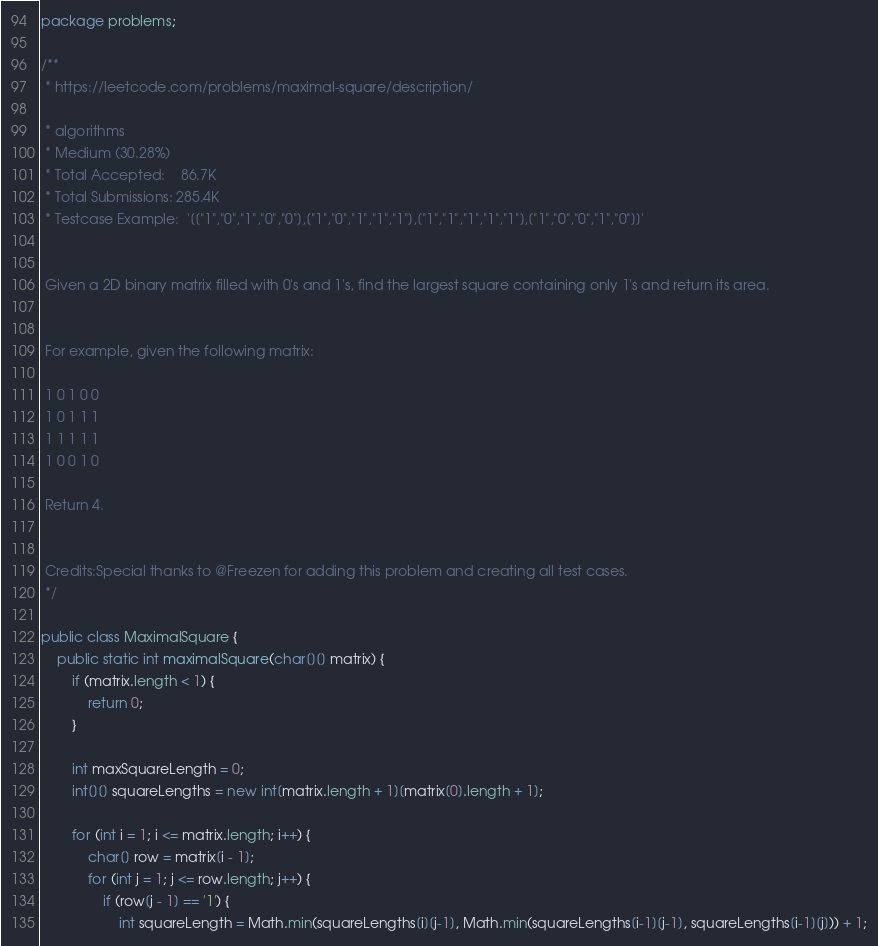<code> <loc_0><loc_0><loc_500><loc_500><_Java_>package problems;

/**
 * https://leetcode.com/problems/maximal-square/description/

 * algorithms
 * Medium (30.28%)
 * Total Accepted:    86.7K
 * Total Submissions: 285.4K
 * Testcase Example:  '[["1","0","1","0","0"],["1","0","1","1","1"],["1","1","1","1","1"],["1","0","0","1","0"]]'


 Given a 2D binary matrix filled with 0's and 1's, find the largest square containing only 1's and return its area.


 For example, given the following matrix:

 1 0 1 0 0
 1 0 1 1 1
 1 1 1 1 1
 1 0 0 1 0

 Return 4.


 Credits:Special thanks to @Freezen for adding this problem and creating all test cases.
 */

public class MaximalSquare {
    public static int maximalSquare(char[][] matrix) {
        if (matrix.length < 1) {
            return 0;
        }

        int maxSquareLength = 0;
        int[][] squareLengths = new int[matrix.length + 1][matrix[0].length + 1];

        for (int i = 1; i <= matrix.length; i++) {
            char[] row = matrix[i - 1];
            for (int j = 1; j <= row.length; j++) {
                if (row[j - 1] == '1') {
                    int squareLength = Math.min(squareLengths[i][j-1], Math.min(squareLengths[i-1][j-1], squareLengths[i-1][j])) + 1;</code> 